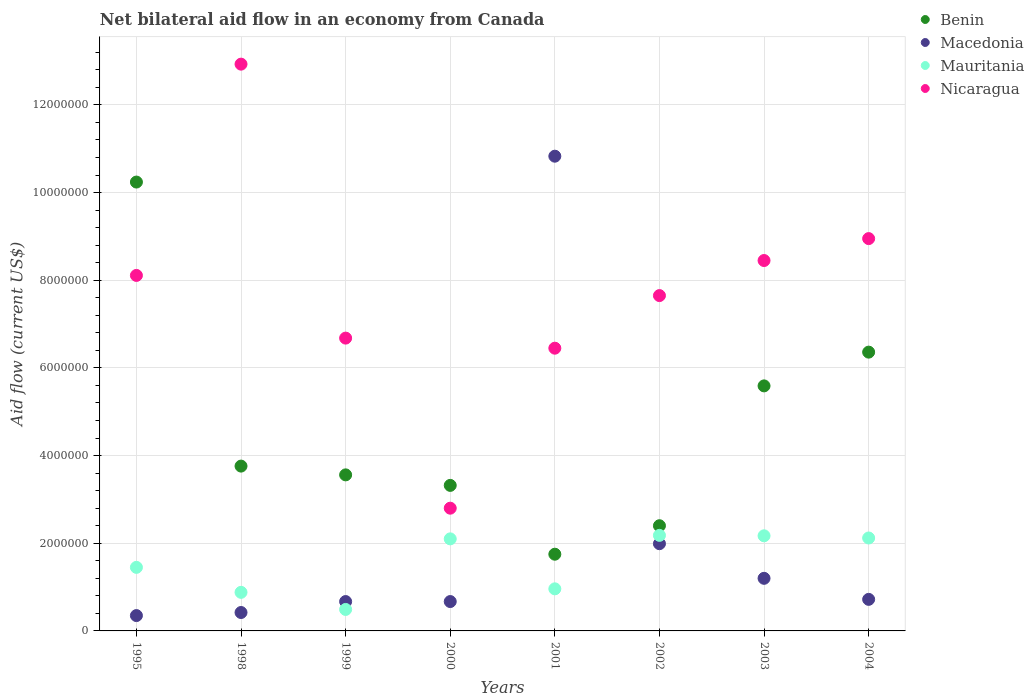What is the net bilateral aid flow in Nicaragua in 2003?
Provide a succinct answer. 8.45e+06. Across all years, what is the maximum net bilateral aid flow in Macedonia?
Give a very brief answer. 1.08e+07. Across all years, what is the minimum net bilateral aid flow in Benin?
Provide a short and direct response. 1.75e+06. What is the total net bilateral aid flow in Mauritania in the graph?
Your answer should be very brief. 1.24e+07. What is the difference between the net bilateral aid flow in Macedonia in 2002 and that in 2003?
Provide a succinct answer. 7.90e+05. What is the difference between the net bilateral aid flow in Nicaragua in 2004 and the net bilateral aid flow in Benin in 1995?
Offer a very short reply. -1.29e+06. What is the average net bilateral aid flow in Macedonia per year?
Keep it short and to the point. 2.11e+06. In the year 1995, what is the difference between the net bilateral aid flow in Macedonia and net bilateral aid flow in Nicaragua?
Offer a terse response. -7.76e+06. What is the ratio of the net bilateral aid flow in Benin in 2001 to that in 2004?
Your answer should be compact. 0.28. Is the difference between the net bilateral aid flow in Macedonia in 1995 and 1998 greater than the difference between the net bilateral aid flow in Nicaragua in 1995 and 1998?
Give a very brief answer. Yes. What is the difference between the highest and the second highest net bilateral aid flow in Macedonia?
Give a very brief answer. 8.84e+06. What is the difference between the highest and the lowest net bilateral aid flow in Benin?
Offer a terse response. 8.49e+06. Is it the case that in every year, the sum of the net bilateral aid flow in Benin and net bilateral aid flow in Nicaragua  is greater than the sum of net bilateral aid flow in Macedonia and net bilateral aid flow in Mauritania?
Offer a terse response. No. Is it the case that in every year, the sum of the net bilateral aid flow in Mauritania and net bilateral aid flow in Nicaragua  is greater than the net bilateral aid flow in Macedonia?
Keep it short and to the point. No. Does the net bilateral aid flow in Nicaragua monotonically increase over the years?
Your answer should be very brief. No. Is the net bilateral aid flow in Mauritania strictly greater than the net bilateral aid flow in Nicaragua over the years?
Keep it short and to the point. No. How many dotlines are there?
Offer a very short reply. 4. How many years are there in the graph?
Offer a terse response. 8. Are the values on the major ticks of Y-axis written in scientific E-notation?
Your answer should be very brief. No. What is the title of the graph?
Provide a succinct answer. Net bilateral aid flow in an economy from Canada. Does "San Marino" appear as one of the legend labels in the graph?
Your response must be concise. No. What is the label or title of the X-axis?
Your response must be concise. Years. What is the label or title of the Y-axis?
Give a very brief answer. Aid flow (current US$). What is the Aid flow (current US$) in Benin in 1995?
Keep it short and to the point. 1.02e+07. What is the Aid flow (current US$) in Macedonia in 1995?
Provide a succinct answer. 3.50e+05. What is the Aid flow (current US$) in Mauritania in 1995?
Ensure brevity in your answer.  1.45e+06. What is the Aid flow (current US$) of Nicaragua in 1995?
Make the answer very short. 8.11e+06. What is the Aid flow (current US$) in Benin in 1998?
Keep it short and to the point. 3.76e+06. What is the Aid flow (current US$) in Macedonia in 1998?
Your answer should be very brief. 4.20e+05. What is the Aid flow (current US$) of Mauritania in 1998?
Your response must be concise. 8.80e+05. What is the Aid flow (current US$) of Nicaragua in 1998?
Keep it short and to the point. 1.29e+07. What is the Aid flow (current US$) of Benin in 1999?
Provide a succinct answer. 3.56e+06. What is the Aid flow (current US$) in Macedonia in 1999?
Offer a terse response. 6.70e+05. What is the Aid flow (current US$) of Mauritania in 1999?
Your response must be concise. 4.90e+05. What is the Aid flow (current US$) in Nicaragua in 1999?
Ensure brevity in your answer.  6.68e+06. What is the Aid flow (current US$) of Benin in 2000?
Offer a very short reply. 3.32e+06. What is the Aid flow (current US$) in Macedonia in 2000?
Offer a terse response. 6.70e+05. What is the Aid flow (current US$) of Mauritania in 2000?
Make the answer very short. 2.10e+06. What is the Aid flow (current US$) in Nicaragua in 2000?
Provide a short and direct response. 2.80e+06. What is the Aid flow (current US$) of Benin in 2001?
Provide a short and direct response. 1.75e+06. What is the Aid flow (current US$) in Macedonia in 2001?
Your answer should be very brief. 1.08e+07. What is the Aid flow (current US$) in Mauritania in 2001?
Provide a short and direct response. 9.60e+05. What is the Aid flow (current US$) in Nicaragua in 2001?
Your answer should be very brief. 6.45e+06. What is the Aid flow (current US$) of Benin in 2002?
Ensure brevity in your answer.  2.40e+06. What is the Aid flow (current US$) in Macedonia in 2002?
Offer a very short reply. 1.99e+06. What is the Aid flow (current US$) in Mauritania in 2002?
Your answer should be compact. 2.18e+06. What is the Aid flow (current US$) of Nicaragua in 2002?
Keep it short and to the point. 7.65e+06. What is the Aid flow (current US$) of Benin in 2003?
Ensure brevity in your answer.  5.59e+06. What is the Aid flow (current US$) in Macedonia in 2003?
Keep it short and to the point. 1.20e+06. What is the Aid flow (current US$) in Mauritania in 2003?
Provide a short and direct response. 2.17e+06. What is the Aid flow (current US$) of Nicaragua in 2003?
Provide a succinct answer. 8.45e+06. What is the Aid flow (current US$) of Benin in 2004?
Keep it short and to the point. 6.36e+06. What is the Aid flow (current US$) of Macedonia in 2004?
Give a very brief answer. 7.20e+05. What is the Aid flow (current US$) of Mauritania in 2004?
Provide a succinct answer. 2.12e+06. What is the Aid flow (current US$) in Nicaragua in 2004?
Provide a succinct answer. 8.95e+06. Across all years, what is the maximum Aid flow (current US$) of Benin?
Provide a succinct answer. 1.02e+07. Across all years, what is the maximum Aid flow (current US$) of Macedonia?
Provide a short and direct response. 1.08e+07. Across all years, what is the maximum Aid flow (current US$) in Mauritania?
Offer a very short reply. 2.18e+06. Across all years, what is the maximum Aid flow (current US$) in Nicaragua?
Ensure brevity in your answer.  1.29e+07. Across all years, what is the minimum Aid flow (current US$) in Benin?
Provide a short and direct response. 1.75e+06. Across all years, what is the minimum Aid flow (current US$) of Mauritania?
Keep it short and to the point. 4.90e+05. Across all years, what is the minimum Aid flow (current US$) of Nicaragua?
Offer a terse response. 2.80e+06. What is the total Aid flow (current US$) of Benin in the graph?
Give a very brief answer. 3.70e+07. What is the total Aid flow (current US$) of Macedonia in the graph?
Your response must be concise. 1.68e+07. What is the total Aid flow (current US$) of Mauritania in the graph?
Your response must be concise. 1.24e+07. What is the total Aid flow (current US$) in Nicaragua in the graph?
Offer a very short reply. 6.20e+07. What is the difference between the Aid flow (current US$) in Benin in 1995 and that in 1998?
Provide a succinct answer. 6.48e+06. What is the difference between the Aid flow (current US$) of Macedonia in 1995 and that in 1998?
Your response must be concise. -7.00e+04. What is the difference between the Aid flow (current US$) of Mauritania in 1995 and that in 1998?
Provide a succinct answer. 5.70e+05. What is the difference between the Aid flow (current US$) in Nicaragua in 1995 and that in 1998?
Offer a very short reply. -4.82e+06. What is the difference between the Aid flow (current US$) in Benin in 1995 and that in 1999?
Offer a terse response. 6.68e+06. What is the difference between the Aid flow (current US$) in Macedonia in 1995 and that in 1999?
Ensure brevity in your answer.  -3.20e+05. What is the difference between the Aid flow (current US$) in Mauritania in 1995 and that in 1999?
Provide a short and direct response. 9.60e+05. What is the difference between the Aid flow (current US$) of Nicaragua in 1995 and that in 1999?
Ensure brevity in your answer.  1.43e+06. What is the difference between the Aid flow (current US$) in Benin in 1995 and that in 2000?
Your answer should be very brief. 6.92e+06. What is the difference between the Aid flow (current US$) of Macedonia in 1995 and that in 2000?
Provide a short and direct response. -3.20e+05. What is the difference between the Aid flow (current US$) of Mauritania in 1995 and that in 2000?
Your answer should be compact. -6.50e+05. What is the difference between the Aid flow (current US$) in Nicaragua in 1995 and that in 2000?
Keep it short and to the point. 5.31e+06. What is the difference between the Aid flow (current US$) of Benin in 1995 and that in 2001?
Provide a succinct answer. 8.49e+06. What is the difference between the Aid flow (current US$) in Macedonia in 1995 and that in 2001?
Provide a succinct answer. -1.05e+07. What is the difference between the Aid flow (current US$) of Mauritania in 1995 and that in 2001?
Your answer should be compact. 4.90e+05. What is the difference between the Aid flow (current US$) in Nicaragua in 1995 and that in 2001?
Your response must be concise. 1.66e+06. What is the difference between the Aid flow (current US$) of Benin in 1995 and that in 2002?
Your response must be concise. 7.84e+06. What is the difference between the Aid flow (current US$) in Macedonia in 1995 and that in 2002?
Your answer should be very brief. -1.64e+06. What is the difference between the Aid flow (current US$) in Mauritania in 1995 and that in 2002?
Offer a terse response. -7.30e+05. What is the difference between the Aid flow (current US$) in Nicaragua in 1995 and that in 2002?
Keep it short and to the point. 4.60e+05. What is the difference between the Aid flow (current US$) in Benin in 1995 and that in 2003?
Your answer should be very brief. 4.65e+06. What is the difference between the Aid flow (current US$) of Macedonia in 1995 and that in 2003?
Offer a very short reply. -8.50e+05. What is the difference between the Aid flow (current US$) of Mauritania in 1995 and that in 2003?
Offer a terse response. -7.20e+05. What is the difference between the Aid flow (current US$) of Benin in 1995 and that in 2004?
Provide a short and direct response. 3.88e+06. What is the difference between the Aid flow (current US$) in Macedonia in 1995 and that in 2004?
Ensure brevity in your answer.  -3.70e+05. What is the difference between the Aid flow (current US$) in Mauritania in 1995 and that in 2004?
Your response must be concise. -6.70e+05. What is the difference between the Aid flow (current US$) in Nicaragua in 1995 and that in 2004?
Ensure brevity in your answer.  -8.40e+05. What is the difference between the Aid flow (current US$) of Nicaragua in 1998 and that in 1999?
Your answer should be compact. 6.25e+06. What is the difference between the Aid flow (current US$) of Macedonia in 1998 and that in 2000?
Offer a very short reply. -2.50e+05. What is the difference between the Aid flow (current US$) of Mauritania in 1998 and that in 2000?
Ensure brevity in your answer.  -1.22e+06. What is the difference between the Aid flow (current US$) in Nicaragua in 1998 and that in 2000?
Ensure brevity in your answer.  1.01e+07. What is the difference between the Aid flow (current US$) in Benin in 1998 and that in 2001?
Make the answer very short. 2.01e+06. What is the difference between the Aid flow (current US$) of Macedonia in 1998 and that in 2001?
Your answer should be compact. -1.04e+07. What is the difference between the Aid flow (current US$) of Nicaragua in 1998 and that in 2001?
Give a very brief answer. 6.48e+06. What is the difference between the Aid flow (current US$) in Benin in 1998 and that in 2002?
Make the answer very short. 1.36e+06. What is the difference between the Aid flow (current US$) of Macedonia in 1998 and that in 2002?
Make the answer very short. -1.57e+06. What is the difference between the Aid flow (current US$) in Mauritania in 1998 and that in 2002?
Keep it short and to the point. -1.30e+06. What is the difference between the Aid flow (current US$) of Nicaragua in 1998 and that in 2002?
Keep it short and to the point. 5.28e+06. What is the difference between the Aid flow (current US$) of Benin in 1998 and that in 2003?
Provide a short and direct response. -1.83e+06. What is the difference between the Aid flow (current US$) of Macedonia in 1998 and that in 2003?
Ensure brevity in your answer.  -7.80e+05. What is the difference between the Aid flow (current US$) in Mauritania in 1998 and that in 2003?
Provide a short and direct response. -1.29e+06. What is the difference between the Aid flow (current US$) in Nicaragua in 1998 and that in 2003?
Provide a short and direct response. 4.48e+06. What is the difference between the Aid flow (current US$) in Benin in 1998 and that in 2004?
Your answer should be very brief. -2.60e+06. What is the difference between the Aid flow (current US$) of Mauritania in 1998 and that in 2004?
Ensure brevity in your answer.  -1.24e+06. What is the difference between the Aid flow (current US$) in Nicaragua in 1998 and that in 2004?
Your response must be concise. 3.98e+06. What is the difference between the Aid flow (current US$) in Benin in 1999 and that in 2000?
Your answer should be very brief. 2.40e+05. What is the difference between the Aid flow (current US$) of Macedonia in 1999 and that in 2000?
Provide a succinct answer. 0. What is the difference between the Aid flow (current US$) of Mauritania in 1999 and that in 2000?
Keep it short and to the point. -1.61e+06. What is the difference between the Aid flow (current US$) of Nicaragua in 1999 and that in 2000?
Provide a succinct answer. 3.88e+06. What is the difference between the Aid flow (current US$) of Benin in 1999 and that in 2001?
Provide a succinct answer. 1.81e+06. What is the difference between the Aid flow (current US$) in Macedonia in 1999 and that in 2001?
Your response must be concise. -1.02e+07. What is the difference between the Aid flow (current US$) of Mauritania in 1999 and that in 2001?
Ensure brevity in your answer.  -4.70e+05. What is the difference between the Aid flow (current US$) of Benin in 1999 and that in 2002?
Keep it short and to the point. 1.16e+06. What is the difference between the Aid flow (current US$) of Macedonia in 1999 and that in 2002?
Your answer should be very brief. -1.32e+06. What is the difference between the Aid flow (current US$) in Mauritania in 1999 and that in 2002?
Your response must be concise. -1.69e+06. What is the difference between the Aid flow (current US$) of Nicaragua in 1999 and that in 2002?
Your answer should be very brief. -9.70e+05. What is the difference between the Aid flow (current US$) in Benin in 1999 and that in 2003?
Offer a very short reply. -2.03e+06. What is the difference between the Aid flow (current US$) in Macedonia in 1999 and that in 2003?
Keep it short and to the point. -5.30e+05. What is the difference between the Aid flow (current US$) in Mauritania in 1999 and that in 2003?
Provide a short and direct response. -1.68e+06. What is the difference between the Aid flow (current US$) of Nicaragua in 1999 and that in 2003?
Your answer should be compact. -1.77e+06. What is the difference between the Aid flow (current US$) of Benin in 1999 and that in 2004?
Give a very brief answer. -2.80e+06. What is the difference between the Aid flow (current US$) of Macedonia in 1999 and that in 2004?
Ensure brevity in your answer.  -5.00e+04. What is the difference between the Aid flow (current US$) of Mauritania in 1999 and that in 2004?
Give a very brief answer. -1.63e+06. What is the difference between the Aid flow (current US$) of Nicaragua in 1999 and that in 2004?
Your answer should be very brief. -2.27e+06. What is the difference between the Aid flow (current US$) in Benin in 2000 and that in 2001?
Provide a short and direct response. 1.57e+06. What is the difference between the Aid flow (current US$) of Macedonia in 2000 and that in 2001?
Offer a terse response. -1.02e+07. What is the difference between the Aid flow (current US$) in Mauritania in 2000 and that in 2001?
Give a very brief answer. 1.14e+06. What is the difference between the Aid flow (current US$) in Nicaragua in 2000 and that in 2001?
Your response must be concise. -3.65e+06. What is the difference between the Aid flow (current US$) of Benin in 2000 and that in 2002?
Give a very brief answer. 9.20e+05. What is the difference between the Aid flow (current US$) of Macedonia in 2000 and that in 2002?
Offer a terse response. -1.32e+06. What is the difference between the Aid flow (current US$) of Mauritania in 2000 and that in 2002?
Your answer should be very brief. -8.00e+04. What is the difference between the Aid flow (current US$) of Nicaragua in 2000 and that in 2002?
Give a very brief answer. -4.85e+06. What is the difference between the Aid flow (current US$) of Benin in 2000 and that in 2003?
Your response must be concise. -2.27e+06. What is the difference between the Aid flow (current US$) in Macedonia in 2000 and that in 2003?
Ensure brevity in your answer.  -5.30e+05. What is the difference between the Aid flow (current US$) of Nicaragua in 2000 and that in 2003?
Your answer should be very brief. -5.65e+06. What is the difference between the Aid flow (current US$) in Benin in 2000 and that in 2004?
Provide a succinct answer. -3.04e+06. What is the difference between the Aid flow (current US$) in Mauritania in 2000 and that in 2004?
Your answer should be very brief. -2.00e+04. What is the difference between the Aid flow (current US$) of Nicaragua in 2000 and that in 2004?
Offer a very short reply. -6.15e+06. What is the difference between the Aid flow (current US$) in Benin in 2001 and that in 2002?
Offer a terse response. -6.50e+05. What is the difference between the Aid flow (current US$) of Macedonia in 2001 and that in 2002?
Make the answer very short. 8.84e+06. What is the difference between the Aid flow (current US$) of Mauritania in 2001 and that in 2002?
Your answer should be very brief. -1.22e+06. What is the difference between the Aid flow (current US$) of Nicaragua in 2001 and that in 2002?
Ensure brevity in your answer.  -1.20e+06. What is the difference between the Aid flow (current US$) in Benin in 2001 and that in 2003?
Provide a succinct answer. -3.84e+06. What is the difference between the Aid flow (current US$) in Macedonia in 2001 and that in 2003?
Your answer should be compact. 9.63e+06. What is the difference between the Aid flow (current US$) of Mauritania in 2001 and that in 2003?
Ensure brevity in your answer.  -1.21e+06. What is the difference between the Aid flow (current US$) in Benin in 2001 and that in 2004?
Keep it short and to the point. -4.61e+06. What is the difference between the Aid flow (current US$) of Macedonia in 2001 and that in 2004?
Give a very brief answer. 1.01e+07. What is the difference between the Aid flow (current US$) of Mauritania in 2001 and that in 2004?
Your response must be concise. -1.16e+06. What is the difference between the Aid flow (current US$) in Nicaragua in 2001 and that in 2004?
Your answer should be very brief. -2.50e+06. What is the difference between the Aid flow (current US$) in Benin in 2002 and that in 2003?
Ensure brevity in your answer.  -3.19e+06. What is the difference between the Aid flow (current US$) of Macedonia in 2002 and that in 2003?
Provide a short and direct response. 7.90e+05. What is the difference between the Aid flow (current US$) of Mauritania in 2002 and that in 2003?
Provide a succinct answer. 10000. What is the difference between the Aid flow (current US$) in Nicaragua in 2002 and that in 2003?
Ensure brevity in your answer.  -8.00e+05. What is the difference between the Aid flow (current US$) in Benin in 2002 and that in 2004?
Make the answer very short. -3.96e+06. What is the difference between the Aid flow (current US$) of Macedonia in 2002 and that in 2004?
Give a very brief answer. 1.27e+06. What is the difference between the Aid flow (current US$) of Mauritania in 2002 and that in 2004?
Provide a short and direct response. 6.00e+04. What is the difference between the Aid flow (current US$) of Nicaragua in 2002 and that in 2004?
Ensure brevity in your answer.  -1.30e+06. What is the difference between the Aid flow (current US$) in Benin in 2003 and that in 2004?
Offer a very short reply. -7.70e+05. What is the difference between the Aid flow (current US$) of Macedonia in 2003 and that in 2004?
Make the answer very short. 4.80e+05. What is the difference between the Aid flow (current US$) of Nicaragua in 2003 and that in 2004?
Keep it short and to the point. -5.00e+05. What is the difference between the Aid flow (current US$) of Benin in 1995 and the Aid flow (current US$) of Macedonia in 1998?
Offer a very short reply. 9.82e+06. What is the difference between the Aid flow (current US$) of Benin in 1995 and the Aid flow (current US$) of Mauritania in 1998?
Keep it short and to the point. 9.36e+06. What is the difference between the Aid flow (current US$) in Benin in 1995 and the Aid flow (current US$) in Nicaragua in 1998?
Provide a short and direct response. -2.69e+06. What is the difference between the Aid flow (current US$) of Macedonia in 1995 and the Aid flow (current US$) of Mauritania in 1998?
Give a very brief answer. -5.30e+05. What is the difference between the Aid flow (current US$) in Macedonia in 1995 and the Aid flow (current US$) in Nicaragua in 1998?
Provide a short and direct response. -1.26e+07. What is the difference between the Aid flow (current US$) of Mauritania in 1995 and the Aid flow (current US$) of Nicaragua in 1998?
Provide a short and direct response. -1.15e+07. What is the difference between the Aid flow (current US$) of Benin in 1995 and the Aid flow (current US$) of Macedonia in 1999?
Ensure brevity in your answer.  9.57e+06. What is the difference between the Aid flow (current US$) of Benin in 1995 and the Aid flow (current US$) of Mauritania in 1999?
Keep it short and to the point. 9.75e+06. What is the difference between the Aid flow (current US$) of Benin in 1995 and the Aid flow (current US$) of Nicaragua in 1999?
Keep it short and to the point. 3.56e+06. What is the difference between the Aid flow (current US$) in Macedonia in 1995 and the Aid flow (current US$) in Nicaragua in 1999?
Keep it short and to the point. -6.33e+06. What is the difference between the Aid flow (current US$) of Mauritania in 1995 and the Aid flow (current US$) of Nicaragua in 1999?
Provide a short and direct response. -5.23e+06. What is the difference between the Aid flow (current US$) in Benin in 1995 and the Aid flow (current US$) in Macedonia in 2000?
Provide a succinct answer. 9.57e+06. What is the difference between the Aid flow (current US$) in Benin in 1995 and the Aid flow (current US$) in Mauritania in 2000?
Your answer should be very brief. 8.14e+06. What is the difference between the Aid flow (current US$) of Benin in 1995 and the Aid flow (current US$) of Nicaragua in 2000?
Your answer should be compact. 7.44e+06. What is the difference between the Aid flow (current US$) of Macedonia in 1995 and the Aid flow (current US$) of Mauritania in 2000?
Make the answer very short. -1.75e+06. What is the difference between the Aid flow (current US$) in Macedonia in 1995 and the Aid flow (current US$) in Nicaragua in 2000?
Make the answer very short. -2.45e+06. What is the difference between the Aid flow (current US$) of Mauritania in 1995 and the Aid flow (current US$) of Nicaragua in 2000?
Your answer should be compact. -1.35e+06. What is the difference between the Aid flow (current US$) in Benin in 1995 and the Aid flow (current US$) in Macedonia in 2001?
Ensure brevity in your answer.  -5.90e+05. What is the difference between the Aid flow (current US$) of Benin in 1995 and the Aid flow (current US$) of Mauritania in 2001?
Provide a short and direct response. 9.28e+06. What is the difference between the Aid flow (current US$) of Benin in 1995 and the Aid flow (current US$) of Nicaragua in 2001?
Your answer should be compact. 3.79e+06. What is the difference between the Aid flow (current US$) of Macedonia in 1995 and the Aid flow (current US$) of Mauritania in 2001?
Offer a terse response. -6.10e+05. What is the difference between the Aid flow (current US$) of Macedonia in 1995 and the Aid flow (current US$) of Nicaragua in 2001?
Give a very brief answer. -6.10e+06. What is the difference between the Aid flow (current US$) of Mauritania in 1995 and the Aid flow (current US$) of Nicaragua in 2001?
Ensure brevity in your answer.  -5.00e+06. What is the difference between the Aid flow (current US$) of Benin in 1995 and the Aid flow (current US$) of Macedonia in 2002?
Ensure brevity in your answer.  8.25e+06. What is the difference between the Aid flow (current US$) in Benin in 1995 and the Aid flow (current US$) in Mauritania in 2002?
Your answer should be very brief. 8.06e+06. What is the difference between the Aid flow (current US$) in Benin in 1995 and the Aid flow (current US$) in Nicaragua in 2002?
Offer a very short reply. 2.59e+06. What is the difference between the Aid flow (current US$) of Macedonia in 1995 and the Aid flow (current US$) of Mauritania in 2002?
Offer a very short reply. -1.83e+06. What is the difference between the Aid flow (current US$) of Macedonia in 1995 and the Aid flow (current US$) of Nicaragua in 2002?
Your answer should be compact. -7.30e+06. What is the difference between the Aid flow (current US$) in Mauritania in 1995 and the Aid flow (current US$) in Nicaragua in 2002?
Give a very brief answer. -6.20e+06. What is the difference between the Aid flow (current US$) in Benin in 1995 and the Aid flow (current US$) in Macedonia in 2003?
Provide a short and direct response. 9.04e+06. What is the difference between the Aid flow (current US$) in Benin in 1995 and the Aid flow (current US$) in Mauritania in 2003?
Give a very brief answer. 8.07e+06. What is the difference between the Aid flow (current US$) of Benin in 1995 and the Aid flow (current US$) of Nicaragua in 2003?
Give a very brief answer. 1.79e+06. What is the difference between the Aid flow (current US$) of Macedonia in 1995 and the Aid flow (current US$) of Mauritania in 2003?
Your response must be concise. -1.82e+06. What is the difference between the Aid flow (current US$) of Macedonia in 1995 and the Aid flow (current US$) of Nicaragua in 2003?
Offer a very short reply. -8.10e+06. What is the difference between the Aid flow (current US$) in Mauritania in 1995 and the Aid flow (current US$) in Nicaragua in 2003?
Offer a very short reply. -7.00e+06. What is the difference between the Aid flow (current US$) of Benin in 1995 and the Aid flow (current US$) of Macedonia in 2004?
Keep it short and to the point. 9.52e+06. What is the difference between the Aid flow (current US$) in Benin in 1995 and the Aid flow (current US$) in Mauritania in 2004?
Keep it short and to the point. 8.12e+06. What is the difference between the Aid flow (current US$) in Benin in 1995 and the Aid flow (current US$) in Nicaragua in 2004?
Keep it short and to the point. 1.29e+06. What is the difference between the Aid flow (current US$) in Macedonia in 1995 and the Aid flow (current US$) in Mauritania in 2004?
Your answer should be compact. -1.77e+06. What is the difference between the Aid flow (current US$) in Macedonia in 1995 and the Aid flow (current US$) in Nicaragua in 2004?
Your response must be concise. -8.60e+06. What is the difference between the Aid flow (current US$) in Mauritania in 1995 and the Aid flow (current US$) in Nicaragua in 2004?
Keep it short and to the point. -7.50e+06. What is the difference between the Aid flow (current US$) of Benin in 1998 and the Aid flow (current US$) of Macedonia in 1999?
Your response must be concise. 3.09e+06. What is the difference between the Aid flow (current US$) of Benin in 1998 and the Aid flow (current US$) of Mauritania in 1999?
Make the answer very short. 3.27e+06. What is the difference between the Aid flow (current US$) in Benin in 1998 and the Aid flow (current US$) in Nicaragua in 1999?
Offer a very short reply. -2.92e+06. What is the difference between the Aid flow (current US$) of Macedonia in 1998 and the Aid flow (current US$) of Mauritania in 1999?
Make the answer very short. -7.00e+04. What is the difference between the Aid flow (current US$) of Macedonia in 1998 and the Aid flow (current US$) of Nicaragua in 1999?
Provide a short and direct response. -6.26e+06. What is the difference between the Aid flow (current US$) of Mauritania in 1998 and the Aid flow (current US$) of Nicaragua in 1999?
Ensure brevity in your answer.  -5.80e+06. What is the difference between the Aid flow (current US$) of Benin in 1998 and the Aid flow (current US$) of Macedonia in 2000?
Keep it short and to the point. 3.09e+06. What is the difference between the Aid flow (current US$) in Benin in 1998 and the Aid flow (current US$) in Mauritania in 2000?
Your response must be concise. 1.66e+06. What is the difference between the Aid flow (current US$) of Benin in 1998 and the Aid flow (current US$) of Nicaragua in 2000?
Offer a terse response. 9.60e+05. What is the difference between the Aid flow (current US$) of Macedonia in 1998 and the Aid flow (current US$) of Mauritania in 2000?
Provide a succinct answer. -1.68e+06. What is the difference between the Aid flow (current US$) in Macedonia in 1998 and the Aid flow (current US$) in Nicaragua in 2000?
Provide a short and direct response. -2.38e+06. What is the difference between the Aid flow (current US$) of Mauritania in 1998 and the Aid flow (current US$) of Nicaragua in 2000?
Make the answer very short. -1.92e+06. What is the difference between the Aid flow (current US$) in Benin in 1998 and the Aid flow (current US$) in Macedonia in 2001?
Your response must be concise. -7.07e+06. What is the difference between the Aid flow (current US$) in Benin in 1998 and the Aid flow (current US$) in Mauritania in 2001?
Your answer should be very brief. 2.80e+06. What is the difference between the Aid flow (current US$) of Benin in 1998 and the Aid flow (current US$) of Nicaragua in 2001?
Keep it short and to the point. -2.69e+06. What is the difference between the Aid flow (current US$) in Macedonia in 1998 and the Aid flow (current US$) in Mauritania in 2001?
Your response must be concise. -5.40e+05. What is the difference between the Aid flow (current US$) of Macedonia in 1998 and the Aid flow (current US$) of Nicaragua in 2001?
Provide a short and direct response. -6.03e+06. What is the difference between the Aid flow (current US$) in Mauritania in 1998 and the Aid flow (current US$) in Nicaragua in 2001?
Give a very brief answer. -5.57e+06. What is the difference between the Aid flow (current US$) of Benin in 1998 and the Aid flow (current US$) of Macedonia in 2002?
Provide a short and direct response. 1.77e+06. What is the difference between the Aid flow (current US$) in Benin in 1998 and the Aid flow (current US$) in Mauritania in 2002?
Make the answer very short. 1.58e+06. What is the difference between the Aid flow (current US$) of Benin in 1998 and the Aid flow (current US$) of Nicaragua in 2002?
Provide a short and direct response. -3.89e+06. What is the difference between the Aid flow (current US$) in Macedonia in 1998 and the Aid flow (current US$) in Mauritania in 2002?
Keep it short and to the point. -1.76e+06. What is the difference between the Aid flow (current US$) of Macedonia in 1998 and the Aid flow (current US$) of Nicaragua in 2002?
Ensure brevity in your answer.  -7.23e+06. What is the difference between the Aid flow (current US$) of Mauritania in 1998 and the Aid flow (current US$) of Nicaragua in 2002?
Keep it short and to the point. -6.77e+06. What is the difference between the Aid flow (current US$) of Benin in 1998 and the Aid flow (current US$) of Macedonia in 2003?
Offer a terse response. 2.56e+06. What is the difference between the Aid flow (current US$) of Benin in 1998 and the Aid flow (current US$) of Mauritania in 2003?
Keep it short and to the point. 1.59e+06. What is the difference between the Aid flow (current US$) in Benin in 1998 and the Aid flow (current US$) in Nicaragua in 2003?
Give a very brief answer. -4.69e+06. What is the difference between the Aid flow (current US$) in Macedonia in 1998 and the Aid flow (current US$) in Mauritania in 2003?
Your answer should be very brief. -1.75e+06. What is the difference between the Aid flow (current US$) in Macedonia in 1998 and the Aid flow (current US$) in Nicaragua in 2003?
Offer a very short reply. -8.03e+06. What is the difference between the Aid flow (current US$) in Mauritania in 1998 and the Aid flow (current US$) in Nicaragua in 2003?
Offer a terse response. -7.57e+06. What is the difference between the Aid flow (current US$) of Benin in 1998 and the Aid flow (current US$) of Macedonia in 2004?
Provide a succinct answer. 3.04e+06. What is the difference between the Aid flow (current US$) in Benin in 1998 and the Aid flow (current US$) in Mauritania in 2004?
Make the answer very short. 1.64e+06. What is the difference between the Aid flow (current US$) in Benin in 1998 and the Aid flow (current US$) in Nicaragua in 2004?
Give a very brief answer. -5.19e+06. What is the difference between the Aid flow (current US$) in Macedonia in 1998 and the Aid flow (current US$) in Mauritania in 2004?
Provide a short and direct response. -1.70e+06. What is the difference between the Aid flow (current US$) in Macedonia in 1998 and the Aid flow (current US$) in Nicaragua in 2004?
Ensure brevity in your answer.  -8.53e+06. What is the difference between the Aid flow (current US$) in Mauritania in 1998 and the Aid flow (current US$) in Nicaragua in 2004?
Your answer should be compact. -8.07e+06. What is the difference between the Aid flow (current US$) in Benin in 1999 and the Aid flow (current US$) in Macedonia in 2000?
Keep it short and to the point. 2.89e+06. What is the difference between the Aid flow (current US$) in Benin in 1999 and the Aid flow (current US$) in Mauritania in 2000?
Ensure brevity in your answer.  1.46e+06. What is the difference between the Aid flow (current US$) of Benin in 1999 and the Aid flow (current US$) of Nicaragua in 2000?
Offer a terse response. 7.60e+05. What is the difference between the Aid flow (current US$) of Macedonia in 1999 and the Aid flow (current US$) of Mauritania in 2000?
Make the answer very short. -1.43e+06. What is the difference between the Aid flow (current US$) of Macedonia in 1999 and the Aid flow (current US$) of Nicaragua in 2000?
Offer a terse response. -2.13e+06. What is the difference between the Aid flow (current US$) of Mauritania in 1999 and the Aid flow (current US$) of Nicaragua in 2000?
Ensure brevity in your answer.  -2.31e+06. What is the difference between the Aid flow (current US$) of Benin in 1999 and the Aid flow (current US$) of Macedonia in 2001?
Provide a succinct answer. -7.27e+06. What is the difference between the Aid flow (current US$) of Benin in 1999 and the Aid flow (current US$) of Mauritania in 2001?
Keep it short and to the point. 2.60e+06. What is the difference between the Aid flow (current US$) in Benin in 1999 and the Aid flow (current US$) in Nicaragua in 2001?
Your response must be concise. -2.89e+06. What is the difference between the Aid flow (current US$) of Macedonia in 1999 and the Aid flow (current US$) of Mauritania in 2001?
Provide a short and direct response. -2.90e+05. What is the difference between the Aid flow (current US$) in Macedonia in 1999 and the Aid flow (current US$) in Nicaragua in 2001?
Your response must be concise. -5.78e+06. What is the difference between the Aid flow (current US$) in Mauritania in 1999 and the Aid flow (current US$) in Nicaragua in 2001?
Your answer should be very brief. -5.96e+06. What is the difference between the Aid flow (current US$) of Benin in 1999 and the Aid flow (current US$) of Macedonia in 2002?
Give a very brief answer. 1.57e+06. What is the difference between the Aid flow (current US$) of Benin in 1999 and the Aid flow (current US$) of Mauritania in 2002?
Provide a succinct answer. 1.38e+06. What is the difference between the Aid flow (current US$) in Benin in 1999 and the Aid flow (current US$) in Nicaragua in 2002?
Your answer should be compact. -4.09e+06. What is the difference between the Aid flow (current US$) in Macedonia in 1999 and the Aid flow (current US$) in Mauritania in 2002?
Your response must be concise. -1.51e+06. What is the difference between the Aid flow (current US$) of Macedonia in 1999 and the Aid flow (current US$) of Nicaragua in 2002?
Your answer should be very brief. -6.98e+06. What is the difference between the Aid flow (current US$) of Mauritania in 1999 and the Aid flow (current US$) of Nicaragua in 2002?
Provide a succinct answer. -7.16e+06. What is the difference between the Aid flow (current US$) of Benin in 1999 and the Aid flow (current US$) of Macedonia in 2003?
Provide a short and direct response. 2.36e+06. What is the difference between the Aid flow (current US$) of Benin in 1999 and the Aid flow (current US$) of Mauritania in 2003?
Provide a succinct answer. 1.39e+06. What is the difference between the Aid flow (current US$) in Benin in 1999 and the Aid flow (current US$) in Nicaragua in 2003?
Make the answer very short. -4.89e+06. What is the difference between the Aid flow (current US$) in Macedonia in 1999 and the Aid flow (current US$) in Mauritania in 2003?
Offer a terse response. -1.50e+06. What is the difference between the Aid flow (current US$) in Macedonia in 1999 and the Aid flow (current US$) in Nicaragua in 2003?
Provide a short and direct response. -7.78e+06. What is the difference between the Aid flow (current US$) of Mauritania in 1999 and the Aid flow (current US$) of Nicaragua in 2003?
Offer a very short reply. -7.96e+06. What is the difference between the Aid flow (current US$) of Benin in 1999 and the Aid flow (current US$) of Macedonia in 2004?
Provide a short and direct response. 2.84e+06. What is the difference between the Aid flow (current US$) of Benin in 1999 and the Aid flow (current US$) of Mauritania in 2004?
Give a very brief answer. 1.44e+06. What is the difference between the Aid flow (current US$) of Benin in 1999 and the Aid flow (current US$) of Nicaragua in 2004?
Your response must be concise. -5.39e+06. What is the difference between the Aid flow (current US$) in Macedonia in 1999 and the Aid flow (current US$) in Mauritania in 2004?
Give a very brief answer. -1.45e+06. What is the difference between the Aid flow (current US$) in Macedonia in 1999 and the Aid flow (current US$) in Nicaragua in 2004?
Your answer should be compact. -8.28e+06. What is the difference between the Aid flow (current US$) of Mauritania in 1999 and the Aid flow (current US$) of Nicaragua in 2004?
Offer a very short reply. -8.46e+06. What is the difference between the Aid flow (current US$) of Benin in 2000 and the Aid flow (current US$) of Macedonia in 2001?
Offer a terse response. -7.51e+06. What is the difference between the Aid flow (current US$) of Benin in 2000 and the Aid flow (current US$) of Mauritania in 2001?
Make the answer very short. 2.36e+06. What is the difference between the Aid flow (current US$) of Benin in 2000 and the Aid flow (current US$) of Nicaragua in 2001?
Offer a very short reply. -3.13e+06. What is the difference between the Aid flow (current US$) of Macedonia in 2000 and the Aid flow (current US$) of Nicaragua in 2001?
Give a very brief answer. -5.78e+06. What is the difference between the Aid flow (current US$) of Mauritania in 2000 and the Aid flow (current US$) of Nicaragua in 2001?
Keep it short and to the point. -4.35e+06. What is the difference between the Aid flow (current US$) in Benin in 2000 and the Aid flow (current US$) in Macedonia in 2002?
Provide a succinct answer. 1.33e+06. What is the difference between the Aid flow (current US$) of Benin in 2000 and the Aid flow (current US$) of Mauritania in 2002?
Ensure brevity in your answer.  1.14e+06. What is the difference between the Aid flow (current US$) of Benin in 2000 and the Aid flow (current US$) of Nicaragua in 2002?
Make the answer very short. -4.33e+06. What is the difference between the Aid flow (current US$) in Macedonia in 2000 and the Aid flow (current US$) in Mauritania in 2002?
Provide a succinct answer. -1.51e+06. What is the difference between the Aid flow (current US$) in Macedonia in 2000 and the Aid flow (current US$) in Nicaragua in 2002?
Your answer should be compact. -6.98e+06. What is the difference between the Aid flow (current US$) in Mauritania in 2000 and the Aid flow (current US$) in Nicaragua in 2002?
Keep it short and to the point. -5.55e+06. What is the difference between the Aid flow (current US$) in Benin in 2000 and the Aid flow (current US$) in Macedonia in 2003?
Offer a very short reply. 2.12e+06. What is the difference between the Aid flow (current US$) of Benin in 2000 and the Aid flow (current US$) of Mauritania in 2003?
Offer a terse response. 1.15e+06. What is the difference between the Aid flow (current US$) in Benin in 2000 and the Aid flow (current US$) in Nicaragua in 2003?
Provide a short and direct response. -5.13e+06. What is the difference between the Aid flow (current US$) of Macedonia in 2000 and the Aid flow (current US$) of Mauritania in 2003?
Keep it short and to the point. -1.50e+06. What is the difference between the Aid flow (current US$) in Macedonia in 2000 and the Aid flow (current US$) in Nicaragua in 2003?
Make the answer very short. -7.78e+06. What is the difference between the Aid flow (current US$) in Mauritania in 2000 and the Aid flow (current US$) in Nicaragua in 2003?
Offer a terse response. -6.35e+06. What is the difference between the Aid flow (current US$) in Benin in 2000 and the Aid flow (current US$) in Macedonia in 2004?
Your answer should be very brief. 2.60e+06. What is the difference between the Aid flow (current US$) in Benin in 2000 and the Aid flow (current US$) in Mauritania in 2004?
Offer a very short reply. 1.20e+06. What is the difference between the Aid flow (current US$) of Benin in 2000 and the Aid flow (current US$) of Nicaragua in 2004?
Give a very brief answer. -5.63e+06. What is the difference between the Aid flow (current US$) in Macedonia in 2000 and the Aid flow (current US$) in Mauritania in 2004?
Make the answer very short. -1.45e+06. What is the difference between the Aid flow (current US$) of Macedonia in 2000 and the Aid flow (current US$) of Nicaragua in 2004?
Provide a short and direct response. -8.28e+06. What is the difference between the Aid flow (current US$) of Mauritania in 2000 and the Aid flow (current US$) of Nicaragua in 2004?
Keep it short and to the point. -6.85e+06. What is the difference between the Aid flow (current US$) in Benin in 2001 and the Aid flow (current US$) in Mauritania in 2002?
Keep it short and to the point. -4.30e+05. What is the difference between the Aid flow (current US$) in Benin in 2001 and the Aid flow (current US$) in Nicaragua in 2002?
Offer a very short reply. -5.90e+06. What is the difference between the Aid flow (current US$) in Macedonia in 2001 and the Aid flow (current US$) in Mauritania in 2002?
Offer a very short reply. 8.65e+06. What is the difference between the Aid flow (current US$) in Macedonia in 2001 and the Aid flow (current US$) in Nicaragua in 2002?
Your response must be concise. 3.18e+06. What is the difference between the Aid flow (current US$) of Mauritania in 2001 and the Aid flow (current US$) of Nicaragua in 2002?
Ensure brevity in your answer.  -6.69e+06. What is the difference between the Aid flow (current US$) of Benin in 2001 and the Aid flow (current US$) of Mauritania in 2003?
Your response must be concise. -4.20e+05. What is the difference between the Aid flow (current US$) of Benin in 2001 and the Aid flow (current US$) of Nicaragua in 2003?
Give a very brief answer. -6.70e+06. What is the difference between the Aid flow (current US$) in Macedonia in 2001 and the Aid flow (current US$) in Mauritania in 2003?
Provide a short and direct response. 8.66e+06. What is the difference between the Aid flow (current US$) in Macedonia in 2001 and the Aid flow (current US$) in Nicaragua in 2003?
Provide a succinct answer. 2.38e+06. What is the difference between the Aid flow (current US$) in Mauritania in 2001 and the Aid flow (current US$) in Nicaragua in 2003?
Your answer should be compact. -7.49e+06. What is the difference between the Aid flow (current US$) of Benin in 2001 and the Aid flow (current US$) of Macedonia in 2004?
Your answer should be very brief. 1.03e+06. What is the difference between the Aid flow (current US$) in Benin in 2001 and the Aid flow (current US$) in Mauritania in 2004?
Make the answer very short. -3.70e+05. What is the difference between the Aid flow (current US$) in Benin in 2001 and the Aid flow (current US$) in Nicaragua in 2004?
Ensure brevity in your answer.  -7.20e+06. What is the difference between the Aid flow (current US$) of Macedonia in 2001 and the Aid flow (current US$) of Mauritania in 2004?
Your response must be concise. 8.71e+06. What is the difference between the Aid flow (current US$) in Macedonia in 2001 and the Aid flow (current US$) in Nicaragua in 2004?
Make the answer very short. 1.88e+06. What is the difference between the Aid flow (current US$) in Mauritania in 2001 and the Aid flow (current US$) in Nicaragua in 2004?
Provide a short and direct response. -7.99e+06. What is the difference between the Aid flow (current US$) in Benin in 2002 and the Aid flow (current US$) in Macedonia in 2003?
Provide a short and direct response. 1.20e+06. What is the difference between the Aid flow (current US$) in Benin in 2002 and the Aid flow (current US$) in Nicaragua in 2003?
Keep it short and to the point. -6.05e+06. What is the difference between the Aid flow (current US$) of Macedonia in 2002 and the Aid flow (current US$) of Mauritania in 2003?
Ensure brevity in your answer.  -1.80e+05. What is the difference between the Aid flow (current US$) in Macedonia in 2002 and the Aid flow (current US$) in Nicaragua in 2003?
Give a very brief answer. -6.46e+06. What is the difference between the Aid flow (current US$) of Mauritania in 2002 and the Aid flow (current US$) of Nicaragua in 2003?
Make the answer very short. -6.27e+06. What is the difference between the Aid flow (current US$) of Benin in 2002 and the Aid flow (current US$) of Macedonia in 2004?
Give a very brief answer. 1.68e+06. What is the difference between the Aid flow (current US$) of Benin in 2002 and the Aid flow (current US$) of Nicaragua in 2004?
Keep it short and to the point. -6.55e+06. What is the difference between the Aid flow (current US$) of Macedonia in 2002 and the Aid flow (current US$) of Mauritania in 2004?
Give a very brief answer. -1.30e+05. What is the difference between the Aid flow (current US$) in Macedonia in 2002 and the Aid flow (current US$) in Nicaragua in 2004?
Your answer should be compact. -6.96e+06. What is the difference between the Aid flow (current US$) of Mauritania in 2002 and the Aid flow (current US$) of Nicaragua in 2004?
Your answer should be compact. -6.77e+06. What is the difference between the Aid flow (current US$) of Benin in 2003 and the Aid flow (current US$) of Macedonia in 2004?
Give a very brief answer. 4.87e+06. What is the difference between the Aid flow (current US$) in Benin in 2003 and the Aid flow (current US$) in Mauritania in 2004?
Provide a short and direct response. 3.47e+06. What is the difference between the Aid flow (current US$) in Benin in 2003 and the Aid flow (current US$) in Nicaragua in 2004?
Offer a very short reply. -3.36e+06. What is the difference between the Aid flow (current US$) in Macedonia in 2003 and the Aid flow (current US$) in Mauritania in 2004?
Your answer should be compact. -9.20e+05. What is the difference between the Aid flow (current US$) in Macedonia in 2003 and the Aid flow (current US$) in Nicaragua in 2004?
Offer a very short reply. -7.75e+06. What is the difference between the Aid flow (current US$) in Mauritania in 2003 and the Aid flow (current US$) in Nicaragua in 2004?
Your answer should be very brief. -6.78e+06. What is the average Aid flow (current US$) in Benin per year?
Provide a short and direct response. 4.62e+06. What is the average Aid flow (current US$) of Macedonia per year?
Make the answer very short. 2.11e+06. What is the average Aid flow (current US$) of Mauritania per year?
Your answer should be compact. 1.54e+06. What is the average Aid flow (current US$) in Nicaragua per year?
Your response must be concise. 7.75e+06. In the year 1995, what is the difference between the Aid flow (current US$) in Benin and Aid flow (current US$) in Macedonia?
Make the answer very short. 9.89e+06. In the year 1995, what is the difference between the Aid flow (current US$) of Benin and Aid flow (current US$) of Mauritania?
Make the answer very short. 8.79e+06. In the year 1995, what is the difference between the Aid flow (current US$) in Benin and Aid flow (current US$) in Nicaragua?
Ensure brevity in your answer.  2.13e+06. In the year 1995, what is the difference between the Aid flow (current US$) of Macedonia and Aid flow (current US$) of Mauritania?
Offer a terse response. -1.10e+06. In the year 1995, what is the difference between the Aid flow (current US$) in Macedonia and Aid flow (current US$) in Nicaragua?
Make the answer very short. -7.76e+06. In the year 1995, what is the difference between the Aid flow (current US$) of Mauritania and Aid flow (current US$) of Nicaragua?
Provide a short and direct response. -6.66e+06. In the year 1998, what is the difference between the Aid flow (current US$) of Benin and Aid flow (current US$) of Macedonia?
Your answer should be very brief. 3.34e+06. In the year 1998, what is the difference between the Aid flow (current US$) of Benin and Aid flow (current US$) of Mauritania?
Offer a very short reply. 2.88e+06. In the year 1998, what is the difference between the Aid flow (current US$) of Benin and Aid flow (current US$) of Nicaragua?
Provide a succinct answer. -9.17e+06. In the year 1998, what is the difference between the Aid flow (current US$) in Macedonia and Aid flow (current US$) in Mauritania?
Provide a short and direct response. -4.60e+05. In the year 1998, what is the difference between the Aid flow (current US$) of Macedonia and Aid flow (current US$) of Nicaragua?
Keep it short and to the point. -1.25e+07. In the year 1998, what is the difference between the Aid flow (current US$) of Mauritania and Aid flow (current US$) of Nicaragua?
Your response must be concise. -1.20e+07. In the year 1999, what is the difference between the Aid flow (current US$) in Benin and Aid flow (current US$) in Macedonia?
Make the answer very short. 2.89e+06. In the year 1999, what is the difference between the Aid flow (current US$) in Benin and Aid flow (current US$) in Mauritania?
Offer a terse response. 3.07e+06. In the year 1999, what is the difference between the Aid flow (current US$) in Benin and Aid flow (current US$) in Nicaragua?
Make the answer very short. -3.12e+06. In the year 1999, what is the difference between the Aid flow (current US$) in Macedonia and Aid flow (current US$) in Mauritania?
Keep it short and to the point. 1.80e+05. In the year 1999, what is the difference between the Aid flow (current US$) in Macedonia and Aid flow (current US$) in Nicaragua?
Make the answer very short. -6.01e+06. In the year 1999, what is the difference between the Aid flow (current US$) in Mauritania and Aid flow (current US$) in Nicaragua?
Provide a short and direct response. -6.19e+06. In the year 2000, what is the difference between the Aid flow (current US$) in Benin and Aid flow (current US$) in Macedonia?
Your answer should be very brief. 2.65e+06. In the year 2000, what is the difference between the Aid flow (current US$) in Benin and Aid flow (current US$) in Mauritania?
Offer a very short reply. 1.22e+06. In the year 2000, what is the difference between the Aid flow (current US$) of Benin and Aid flow (current US$) of Nicaragua?
Your response must be concise. 5.20e+05. In the year 2000, what is the difference between the Aid flow (current US$) in Macedonia and Aid flow (current US$) in Mauritania?
Your answer should be very brief. -1.43e+06. In the year 2000, what is the difference between the Aid flow (current US$) in Macedonia and Aid flow (current US$) in Nicaragua?
Make the answer very short. -2.13e+06. In the year 2000, what is the difference between the Aid flow (current US$) of Mauritania and Aid flow (current US$) of Nicaragua?
Your response must be concise. -7.00e+05. In the year 2001, what is the difference between the Aid flow (current US$) in Benin and Aid flow (current US$) in Macedonia?
Your answer should be compact. -9.08e+06. In the year 2001, what is the difference between the Aid flow (current US$) in Benin and Aid flow (current US$) in Mauritania?
Provide a succinct answer. 7.90e+05. In the year 2001, what is the difference between the Aid flow (current US$) of Benin and Aid flow (current US$) of Nicaragua?
Your answer should be very brief. -4.70e+06. In the year 2001, what is the difference between the Aid flow (current US$) in Macedonia and Aid flow (current US$) in Mauritania?
Your answer should be compact. 9.87e+06. In the year 2001, what is the difference between the Aid flow (current US$) in Macedonia and Aid flow (current US$) in Nicaragua?
Keep it short and to the point. 4.38e+06. In the year 2001, what is the difference between the Aid flow (current US$) of Mauritania and Aid flow (current US$) of Nicaragua?
Make the answer very short. -5.49e+06. In the year 2002, what is the difference between the Aid flow (current US$) of Benin and Aid flow (current US$) of Macedonia?
Make the answer very short. 4.10e+05. In the year 2002, what is the difference between the Aid flow (current US$) of Benin and Aid flow (current US$) of Mauritania?
Ensure brevity in your answer.  2.20e+05. In the year 2002, what is the difference between the Aid flow (current US$) in Benin and Aid flow (current US$) in Nicaragua?
Ensure brevity in your answer.  -5.25e+06. In the year 2002, what is the difference between the Aid flow (current US$) in Macedonia and Aid flow (current US$) in Mauritania?
Make the answer very short. -1.90e+05. In the year 2002, what is the difference between the Aid flow (current US$) of Macedonia and Aid flow (current US$) of Nicaragua?
Make the answer very short. -5.66e+06. In the year 2002, what is the difference between the Aid flow (current US$) in Mauritania and Aid flow (current US$) in Nicaragua?
Your answer should be compact. -5.47e+06. In the year 2003, what is the difference between the Aid flow (current US$) of Benin and Aid flow (current US$) of Macedonia?
Ensure brevity in your answer.  4.39e+06. In the year 2003, what is the difference between the Aid flow (current US$) of Benin and Aid flow (current US$) of Mauritania?
Offer a very short reply. 3.42e+06. In the year 2003, what is the difference between the Aid flow (current US$) of Benin and Aid flow (current US$) of Nicaragua?
Offer a terse response. -2.86e+06. In the year 2003, what is the difference between the Aid flow (current US$) in Macedonia and Aid flow (current US$) in Mauritania?
Give a very brief answer. -9.70e+05. In the year 2003, what is the difference between the Aid flow (current US$) of Macedonia and Aid flow (current US$) of Nicaragua?
Keep it short and to the point. -7.25e+06. In the year 2003, what is the difference between the Aid flow (current US$) in Mauritania and Aid flow (current US$) in Nicaragua?
Offer a terse response. -6.28e+06. In the year 2004, what is the difference between the Aid flow (current US$) in Benin and Aid flow (current US$) in Macedonia?
Keep it short and to the point. 5.64e+06. In the year 2004, what is the difference between the Aid flow (current US$) in Benin and Aid flow (current US$) in Mauritania?
Your answer should be compact. 4.24e+06. In the year 2004, what is the difference between the Aid flow (current US$) of Benin and Aid flow (current US$) of Nicaragua?
Ensure brevity in your answer.  -2.59e+06. In the year 2004, what is the difference between the Aid flow (current US$) of Macedonia and Aid flow (current US$) of Mauritania?
Provide a short and direct response. -1.40e+06. In the year 2004, what is the difference between the Aid flow (current US$) in Macedonia and Aid flow (current US$) in Nicaragua?
Provide a succinct answer. -8.23e+06. In the year 2004, what is the difference between the Aid flow (current US$) of Mauritania and Aid flow (current US$) of Nicaragua?
Your answer should be very brief. -6.83e+06. What is the ratio of the Aid flow (current US$) of Benin in 1995 to that in 1998?
Offer a terse response. 2.72. What is the ratio of the Aid flow (current US$) in Macedonia in 1995 to that in 1998?
Your answer should be very brief. 0.83. What is the ratio of the Aid flow (current US$) in Mauritania in 1995 to that in 1998?
Offer a very short reply. 1.65. What is the ratio of the Aid flow (current US$) in Nicaragua in 1995 to that in 1998?
Your answer should be compact. 0.63. What is the ratio of the Aid flow (current US$) in Benin in 1995 to that in 1999?
Offer a terse response. 2.88. What is the ratio of the Aid flow (current US$) of Macedonia in 1995 to that in 1999?
Provide a short and direct response. 0.52. What is the ratio of the Aid flow (current US$) of Mauritania in 1995 to that in 1999?
Offer a very short reply. 2.96. What is the ratio of the Aid flow (current US$) in Nicaragua in 1995 to that in 1999?
Your response must be concise. 1.21. What is the ratio of the Aid flow (current US$) of Benin in 1995 to that in 2000?
Your answer should be very brief. 3.08. What is the ratio of the Aid flow (current US$) in Macedonia in 1995 to that in 2000?
Offer a terse response. 0.52. What is the ratio of the Aid flow (current US$) in Mauritania in 1995 to that in 2000?
Offer a terse response. 0.69. What is the ratio of the Aid flow (current US$) of Nicaragua in 1995 to that in 2000?
Offer a terse response. 2.9. What is the ratio of the Aid flow (current US$) of Benin in 1995 to that in 2001?
Ensure brevity in your answer.  5.85. What is the ratio of the Aid flow (current US$) of Macedonia in 1995 to that in 2001?
Your response must be concise. 0.03. What is the ratio of the Aid flow (current US$) in Mauritania in 1995 to that in 2001?
Make the answer very short. 1.51. What is the ratio of the Aid flow (current US$) in Nicaragua in 1995 to that in 2001?
Offer a terse response. 1.26. What is the ratio of the Aid flow (current US$) in Benin in 1995 to that in 2002?
Offer a terse response. 4.27. What is the ratio of the Aid flow (current US$) in Macedonia in 1995 to that in 2002?
Provide a short and direct response. 0.18. What is the ratio of the Aid flow (current US$) in Mauritania in 1995 to that in 2002?
Give a very brief answer. 0.67. What is the ratio of the Aid flow (current US$) of Nicaragua in 1995 to that in 2002?
Offer a terse response. 1.06. What is the ratio of the Aid flow (current US$) of Benin in 1995 to that in 2003?
Your response must be concise. 1.83. What is the ratio of the Aid flow (current US$) of Macedonia in 1995 to that in 2003?
Offer a terse response. 0.29. What is the ratio of the Aid flow (current US$) of Mauritania in 1995 to that in 2003?
Keep it short and to the point. 0.67. What is the ratio of the Aid flow (current US$) in Nicaragua in 1995 to that in 2003?
Ensure brevity in your answer.  0.96. What is the ratio of the Aid flow (current US$) of Benin in 1995 to that in 2004?
Give a very brief answer. 1.61. What is the ratio of the Aid flow (current US$) of Macedonia in 1995 to that in 2004?
Ensure brevity in your answer.  0.49. What is the ratio of the Aid flow (current US$) in Mauritania in 1995 to that in 2004?
Give a very brief answer. 0.68. What is the ratio of the Aid flow (current US$) of Nicaragua in 1995 to that in 2004?
Make the answer very short. 0.91. What is the ratio of the Aid flow (current US$) of Benin in 1998 to that in 1999?
Keep it short and to the point. 1.06. What is the ratio of the Aid flow (current US$) in Macedonia in 1998 to that in 1999?
Your answer should be very brief. 0.63. What is the ratio of the Aid flow (current US$) in Mauritania in 1998 to that in 1999?
Provide a succinct answer. 1.8. What is the ratio of the Aid flow (current US$) of Nicaragua in 1998 to that in 1999?
Provide a short and direct response. 1.94. What is the ratio of the Aid flow (current US$) in Benin in 1998 to that in 2000?
Give a very brief answer. 1.13. What is the ratio of the Aid flow (current US$) in Macedonia in 1998 to that in 2000?
Offer a terse response. 0.63. What is the ratio of the Aid flow (current US$) of Mauritania in 1998 to that in 2000?
Keep it short and to the point. 0.42. What is the ratio of the Aid flow (current US$) in Nicaragua in 1998 to that in 2000?
Make the answer very short. 4.62. What is the ratio of the Aid flow (current US$) of Benin in 1998 to that in 2001?
Provide a short and direct response. 2.15. What is the ratio of the Aid flow (current US$) in Macedonia in 1998 to that in 2001?
Make the answer very short. 0.04. What is the ratio of the Aid flow (current US$) of Nicaragua in 1998 to that in 2001?
Make the answer very short. 2. What is the ratio of the Aid flow (current US$) in Benin in 1998 to that in 2002?
Your answer should be very brief. 1.57. What is the ratio of the Aid flow (current US$) in Macedonia in 1998 to that in 2002?
Offer a very short reply. 0.21. What is the ratio of the Aid flow (current US$) in Mauritania in 1998 to that in 2002?
Your response must be concise. 0.4. What is the ratio of the Aid flow (current US$) in Nicaragua in 1998 to that in 2002?
Provide a short and direct response. 1.69. What is the ratio of the Aid flow (current US$) in Benin in 1998 to that in 2003?
Provide a succinct answer. 0.67. What is the ratio of the Aid flow (current US$) in Mauritania in 1998 to that in 2003?
Your answer should be very brief. 0.41. What is the ratio of the Aid flow (current US$) in Nicaragua in 1998 to that in 2003?
Offer a terse response. 1.53. What is the ratio of the Aid flow (current US$) of Benin in 1998 to that in 2004?
Provide a short and direct response. 0.59. What is the ratio of the Aid flow (current US$) of Macedonia in 1998 to that in 2004?
Offer a terse response. 0.58. What is the ratio of the Aid flow (current US$) of Mauritania in 1998 to that in 2004?
Offer a terse response. 0.42. What is the ratio of the Aid flow (current US$) of Nicaragua in 1998 to that in 2004?
Keep it short and to the point. 1.44. What is the ratio of the Aid flow (current US$) in Benin in 1999 to that in 2000?
Provide a short and direct response. 1.07. What is the ratio of the Aid flow (current US$) in Macedonia in 1999 to that in 2000?
Make the answer very short. 1. What is the ratio of the Aid flow (current US$) in Mauritania in 1999 to that in 2000?
Keep it short and to the point. 0.23. What is the ratio of the Aid flow (current US$) of Nicaragua in 1999 to that in 2000?
Your answer should be very brief. 2.39. What is the ratio of the Aid flow (current US$) of Benin in 1999 to that in 2001?
Keep it short and to the point. 2.03. What is the ratio of the Aid flow (current US$) in Macedonia in 1999 to that in 2001?
Offer a very short reply. 0.06. What is the ratio of the Aid flow (current US$) in Mauritania in 1999 to that in 2001?
Offer a terse response. 0.51. What is the ratio of the Aid flow (current US$) in Nicaragua in 1999 to that in 2001?
Your response must be concise. 1.04. What is the ratio of the Aid flow (current US$) in Benin in 1999 to that in 2002?
Provide a succinct answer. 1.48. What is the ratio of the Aid flow (current US$) of Macedonia in 1999 to that in 2002?
Provide a succinct answer. 0.34. What is the ratio of the Aid flow (current US$) in Mauritania in 1999 to that in 2002?
Give a very brief answer. 0.22. What is the ratio of the Aid flow (current US$) of Nicaragua in 1999 to that in 2002?
Your response must be concise. 0.87. What is the ratio of the Aid flow (current US$) in Benin in 1999 to that in 2003?
Keep it short and to the point. 0.64. What is the ratio of the Aid flow (current US$) in Macedonia in 1999 to that in 2003?
Your response must be concise. 0.56. What is the ratio of the Aid flow (current US$) of Mauritania in 1999 to that in 2003?
Offer a very short reply. 0.23. What is the ratio of the Aid flow (current US$) in Nicaragua in 1999 to that in 2003?
Make the answer very short. 0.79. What is the ratio of the Aid flow (current US$) in Benin in 1999 to that in 2004?
Provide a short and direct response. 0.56. What is the ratio of the Aid flow (current US$) in Macedonia in 1999 to that in 2004?
Provide a succinct answer. 0.93. What is the ratio of the Aid flow (current US$) in Mauritania in 1999 to that in 2004?
Make the answer very short. 0.23. What is the ratio of the Aid flow (current US$) of Nicaragua in 1999 to that in 2004?
Ensure brevity in your answer.  0.75. What is the ratio of the Aid flow (current US$) in Benin in 2000 to that in 2001?
Make the answer very short. 1.9. What is the ratio of the Aid flow (current US$) of Macedonia in 2000 to that in 2001?
Offer a terse response. 0.06. What is the ratio of the Aid flow (current US$) of Mauritania in 2000 to that in 2001?
Ensure brevity in your answer.  2.19. What is the ratio of the Aid flow (current US$) in Nicaragua in 2000 to that in 2001?
Your response must be concise. 0.43. What is the ratio of the Aid flow (current US$) in Benin in 2000 to that in 2002?
Provide a short and direct response. 1.38. What is the ratio of the Aid flow (current US$) in Macedonia in 2000 to that in 2002?
Ensure brevity in your answer.  0.34. What is the ratio of the Aid flow (current US$) of Mauritania in 2000 to that in 2002?
Ensure brevity in your answer.  0.96. What is the ratio of the Aid flow (current US$) in Nicaragua in 2000 to that in 2002?
Provide a short and direct response. 0.37. What is the ratio of the Aid flow (current US$) of Benin in 2000 to that in 2003?
Offer a terse response. 0.59. What is the ratio of the Aid flow (current US$) in Macedonia in 2000 to that in 2003?
Your answer should be compact. 0.56. What is the ratio of the Aid flow (current US$) of Mauritania in 2000 to that in 2003?
Your response must be concise. 0.97. What is the ratio of the Aid flow (current US$) in Nicaragua in 2000 to that in 2003?
Keep it short and to the point. 0.33. What is the ratio of the Aid flow (current US$) in Benin in 2000 to that in 2004?
Provide a short and direct response. 0.52. What is the ratio of the Aid flow (current US$) of Macedonia in 2000 to that in 2004?
Offer a very short reply. 0.93. What is the ratio of the Aid flow (current US$) in Mauritania in 2000 to that in 2004?
Make the answer very short. 0.99. What is the ratio of the Aid flow (current US$) of Nicaragua in 2000 to that in 2004?
Ensure brevity in your answer.  0.31. What is the ratio of the Aid flow (current US$) of Benin in 2001 to that in 2002?
Ensure brevity in your answer.  0.73. What is the ratio of the Aid flow (current US$) of Macedonia in 2001 to that in 2002?
Keep it short and to the point. 5.44. What is the ratio of the Aid flow (current US$) in Mauritania in 2001 to that in 2002?
Your answer should be compact. 0.44. What is the ratio of the Aid flow (current US$) in Nicaragua in 2001 to that in 2002?
Make the answer very short. 0.84. What is the ratio of the Aid flow (current US$) of Benin in 2001 to that in 2003?
Your response must be concise. 0.31. What is the ratio of the Aid flow (current US$) of Macedonia in 2001 to that in 2003?
Ensure brevity in your answer.  9.03. What is the ratio of the Aid flow (current US$) of Mauritania in 2001 to that in 2003?
Offer a terse response. 0.44. What is the ratio of the Aid flow (current US$) of Nicaragua in 2001 to that in 2003?
Provide a short and direct response. 0.76. What is the ratio of the Aid flow (current US$) of Benin in 2001 to that in 2004?
Your answer should be very brief. 0.28. What is the ratio of the Aid flow (current US$) of Macedonia in 2001 to that in 2004?
Offer a very short reply. 15.04. What is the ratio of the Aid flow (current US$) of Mauritania in 2001 to that in 2004?
Your answer should be very brief. 0.45. What is the ratio of the Aid flow (current US$) in Nicaragua in 2001 to that in 2004?
Provide a short and direct response. 0.72. What is the ratio of the Aid flow (current US$) of Benin in 2002 to that in 2003?
Provide a succinct answer. 0.43. What is the ratio of the Aid flow (current US$) of Macedonia in 2002 to that in 2003?
Offer a very short reply. 1.66. What is the ratio of the Aid flow (current US$) in Mauritania in 2002 to that in 2003?
Keep it short and to the point. 1. What is the ratio of the Aid flow (current US$) in Nicaragua in 2002 to that in 2003?
Ensure brevity in your answer.  0.91. What is the ratio of the Aid flow (current US$) in Benin in 2002 to that in 2004?
Make the answer very short. 0.38. What is the ratio of the Aid flow (current US$) in Macedonia in 2002 to that in 2004?
Provide a short and direct response. 2.76. What is the ratio of the Aid flow (current US$) in Mauritania in 2002 to that in 2004?
Offer a very short reply. 1.03. What is the ratio of the Aid flow (current US$) in Nicaragua in 2002 to that in 2004?
Ensure brevity in your answer.  0.85. What is the ratio of the Aid flow (current US$) in Benin in 2003 to that in 2004?
Give a very brief answer. 0.88. What is the ratio of the Aid flow (current US$) in Mauritania in 2003 to that in 2004?
Make the answer very short. 1.02. What is the ratio of the Aid flow (current US$) in Nicaragua in 2003 to that in 2004?
Your response must be concise. 0.94. What is the difference between the highest and the second highest Aid flow (current US$) in Benin?
Give a very brief answer. 3.88e+06. What is the difference between the highest and the second highest Aid flow (current US$) of Macedonia?
Offer a terse response. 8.84e+06. What is the difference between the highest and the second highest Aid flow (current US$) of Nicaragua?
Ensure brevity in your answer.  3.98e+06. What is the difference between the highest and the lowest Aid flow (current US$) of Benin?
Give a very brief answer. 8.49e+06. What is the difference between the highest and the lowest Aid flow (current US$) of Macedonia?
Your response must be concise. 1.05e+07. What is the difference between the highest and the lowest Aid flow (current US$) of Mauritania?
Give a very brief answer. 1.69e+06. What is the difference between the highest and the lowest Aid flow (current US$) in Nicaragua?
Give a very brief answer. 1.01e+07. 